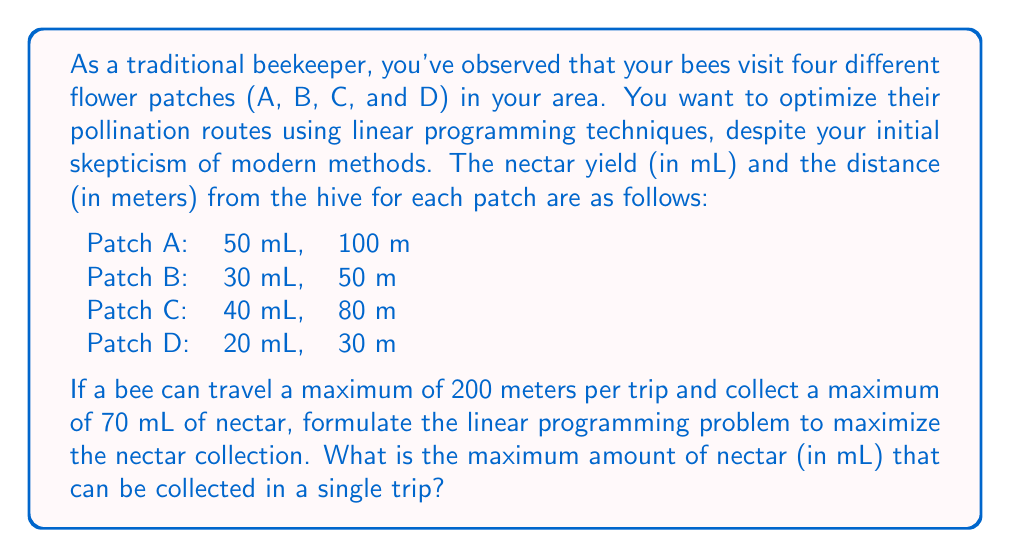Teach me how to tackle this problem. Let's approach this step-by-step:

1) Define variables:
   Let $x_A$, $x_B$, $x_C$, and $x_D$ be the number of visits to patches A, B, C, and D respectively.

2) Objective function:
   We want to maximize the total nectar collected:
   $$ \text{Maximize } Z = 50x_A + 30x_B + 40x_C + 20x_D $$

3) Constraints:
   a) Distance constraint:
      $$ 100x_A + 50x_B + 80x_C + 30x_D \leq 200 $$
   
   b) Nectar capacity constraint:
      $$ 50x_A + 30x_B + 40x_C + 20x_D \leq 70 $$
   
   c) Non-negativity constraints:
      $$ x_A, x_B, x_C, x_D \geq 0 $$

4) Solve using the simplex method or a linear programming solver.

5) The optimal solution is:
   $x_A = 0$, $x_B = 0$, $x_C = 1.75$, $x_D = 0$

6) The maximum nectar collected:
   $$ Z = 40 \times 1.75 = 70 \text{ mL} $$

This solution suggests that the bee should visit patch C 1.75 times (in practice, this means visiting patch C twice, but not fully on the second visit) to collect the maximum amount of nectar within the given constraints.
Answer: 70 mL 